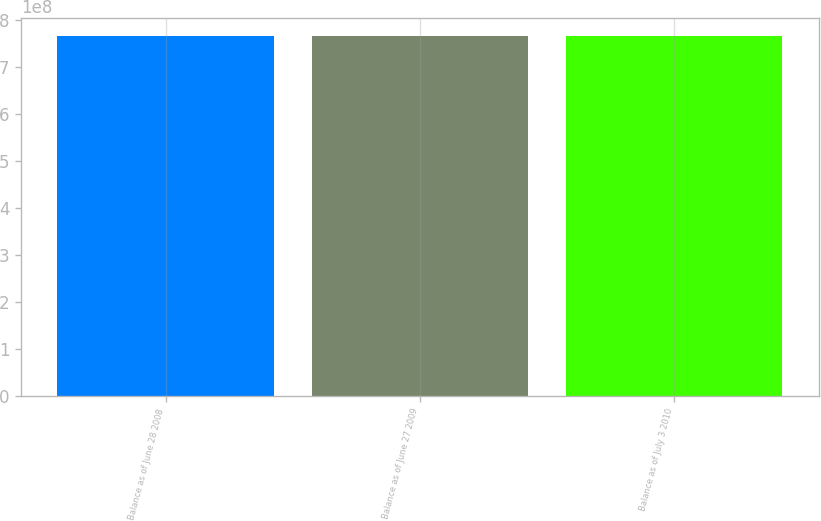<chart> <loc_0><loc_0><loc_500><loc_500><bar_chart><fcel>Balance as of June 28 2008<fcel>Balance as of June 27 2009<fcel>Balance as of July 3 2010<nl><fcel>7.65175e+08<fcel>7.65175e+08<fcel>7.65175e+08<nl></chart> 